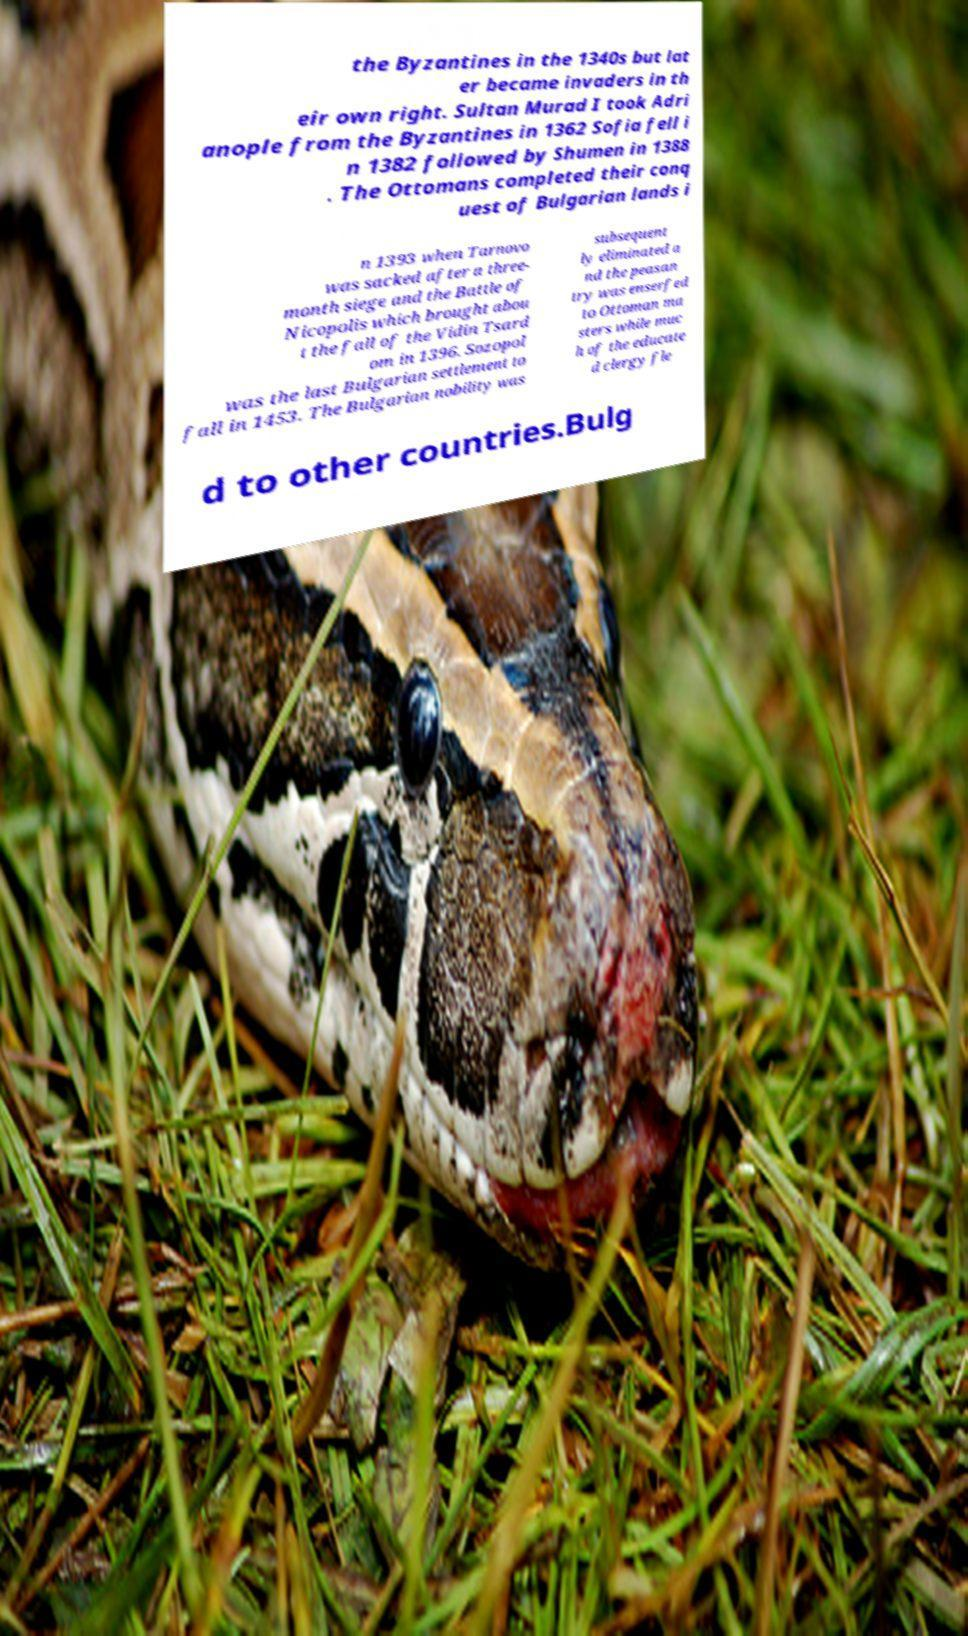Please identify and transcribe the text found in this image. the Byzantines in the 1340s but lat er became invaders in th eir own right. Sultan Murad I took Adri anople from the Byzantines in 1362 Sofia fell i n 1382 followed by Shumen in 1388 . The Ottomans completed their conq uest of Bulgarian lands i n 1393 when Tarnovo was sacked after a three- month siege and the Battle of Nicopolis which brought abou t the fall of the Vidin Tsard om in 1396. Sozopol was the last Bulgarian settlement to fall in 1453. The Bulgarian nobility was subsequent ly eliminated a nd the peasan try was enserfed to Ottoman ma sters while muc h of the educate d clergy fle d to other countries.Bulg 